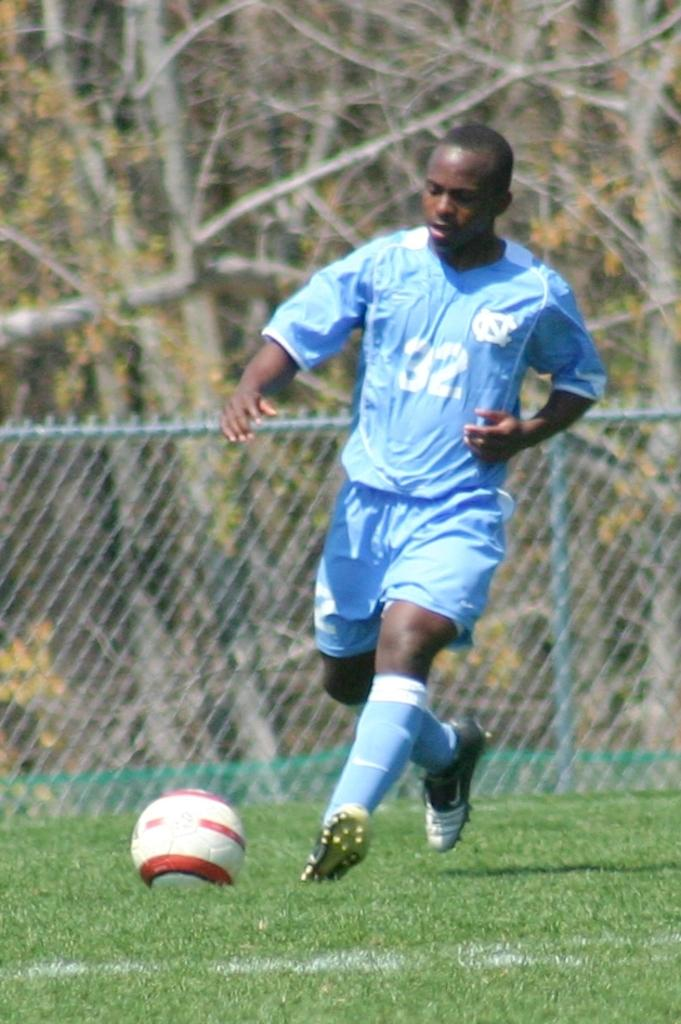What type of surface is at the bottom of the image? There is grass at the bottom of the image. Who is present in the image? A man is present in the image. What is the man wearing? The man is wearing a t-shirt and shorts. What activity is the man engaged in? The man is playing football. What can be seen in the background of the image? There is a railing and trees in the background of the image. What type of van can be seen parked near the trees in the image? There is no van present in the image; it only features a man playing football on grass, with a railing and trees in the background. What button is the man wearing on his t-shirt in the image? The man's t-shirt does not have any visible buttons in the image. 